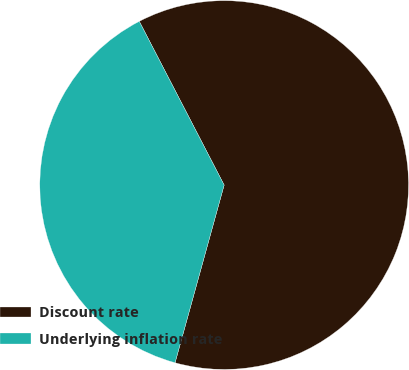<chart> <loc_0><loc_0><loc_500><loc_500><pie_chart><fcel>Discount rate<fcel>Underlying inflation rate<nl><fcel>61.9%<fcel>38.1%<nl></chart> 